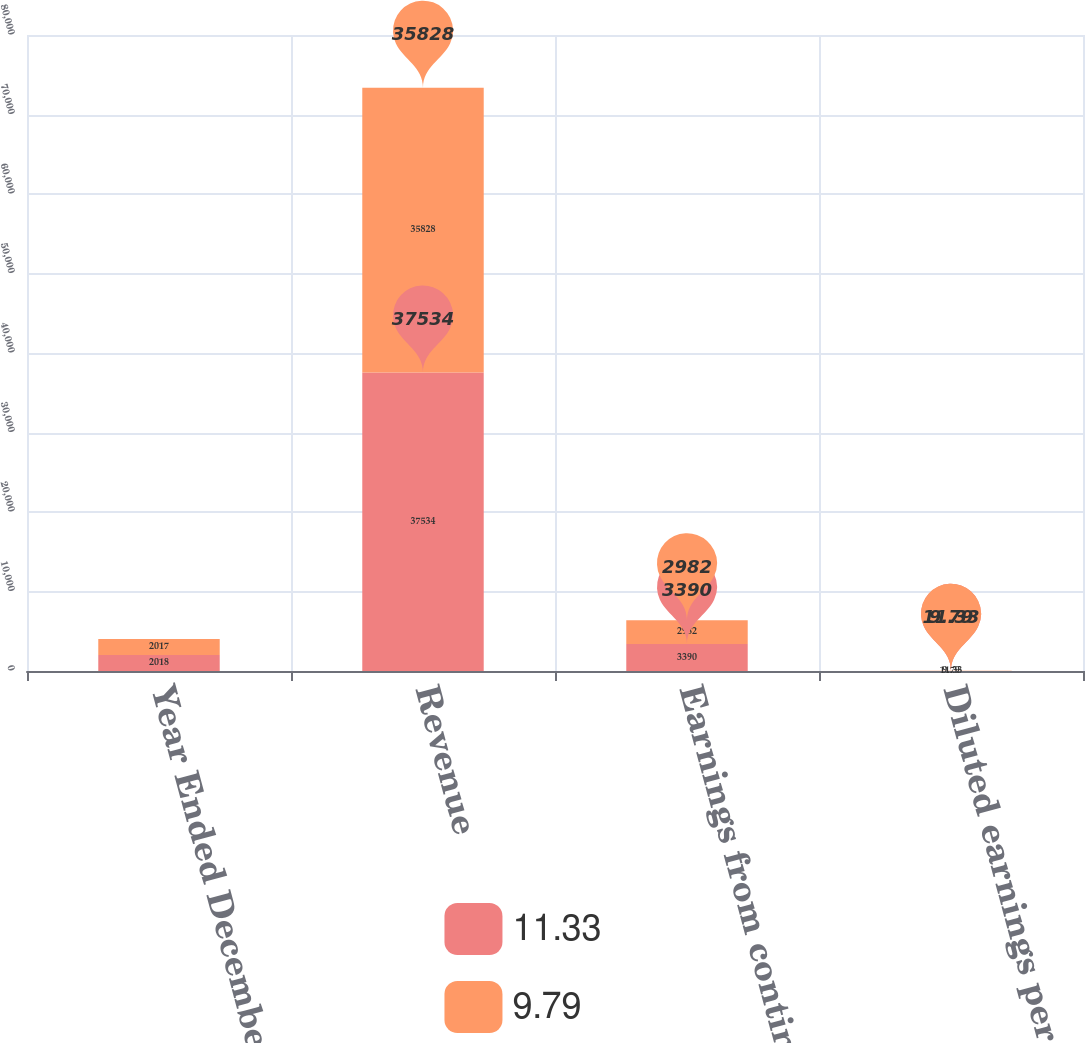Convert chart to OTSL. <chart><loc_0><loc_0><loc_500><loc_500><stacked_bar_chart><ecel><fcel>Year Ended December 31<fcel>Revenue<fcel>Earnings from continuing<fcel>Diluted earnings per share<nl><fcel>11.33<fcel>2018<fcel>37534<fcel>3390<fcel>11.33<nl><fcel>9.79<fcel>2017<fcel>35828<fcel>2982<fcel>9.79<nl></chart> 